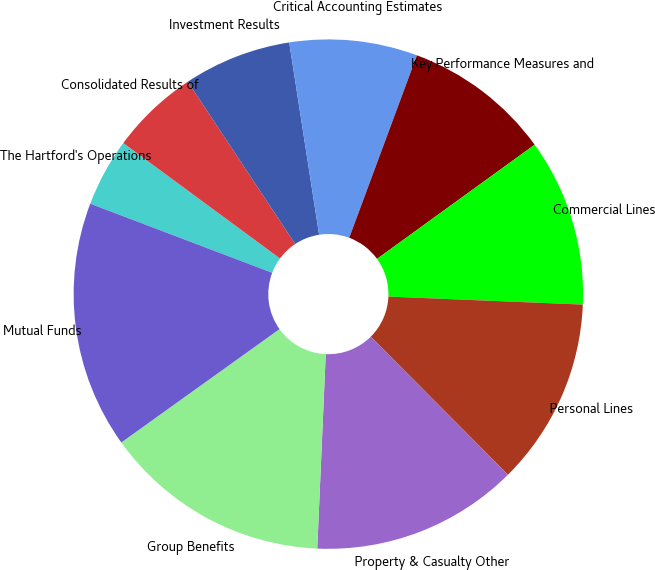<chart> <loc_0><loc_0><loc_500><loc_500><pie_chart><fcel>The Hartford's Operations<fcel>Consolidated Results of<fcel>Investment Results<fcel>Critical Accounting Estimates<fcel>Key Performance Measures and<fcel>Commercial Lines<fcel>Personal Lines<fcel>Property & Casualty Other<fcel>Group Benefits<fcel>Mutual Funds<nl><fcel>4.33%<fcel>5.59%<fcel>6.85%<fcel>8.11%<fcel>9.37%<fcel>10.63%<fcel>11.89%<fcel>13.15%<fcel>14.41%<fcel>15.67%<nl></chart> 